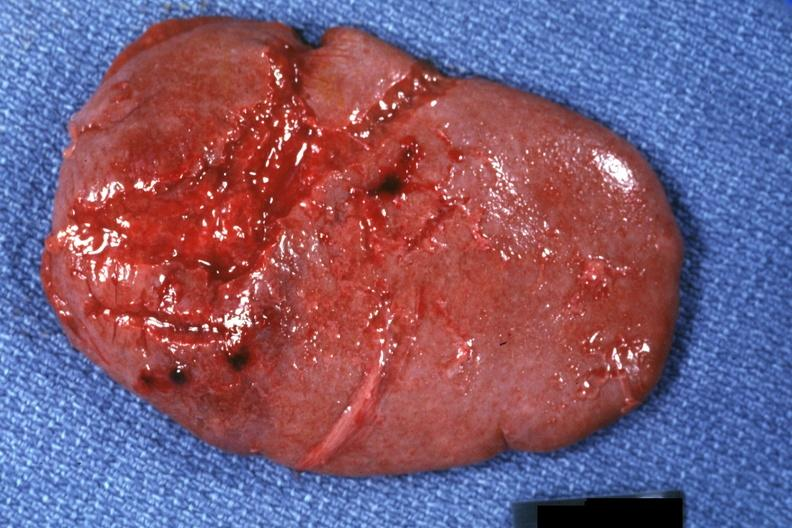what is present?
Answer the question using a single word or phrase. Traumatic rupture 